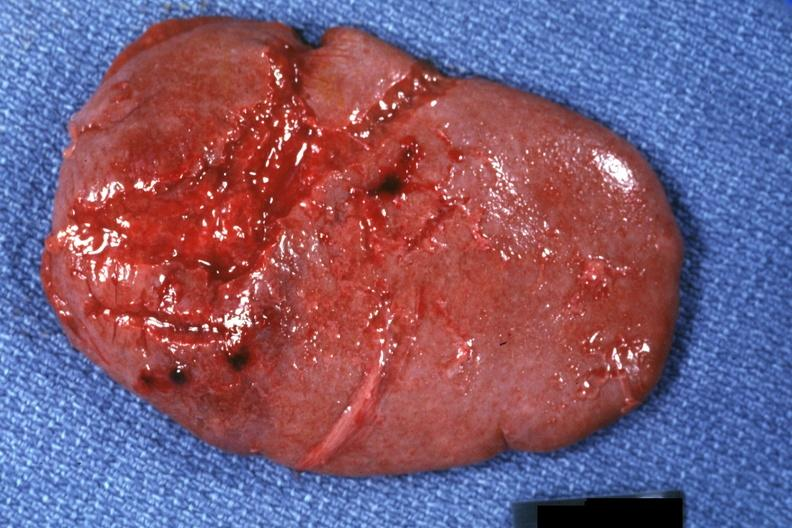what is present?
Answer the question using a single word or phrase. Traumatic rupture 